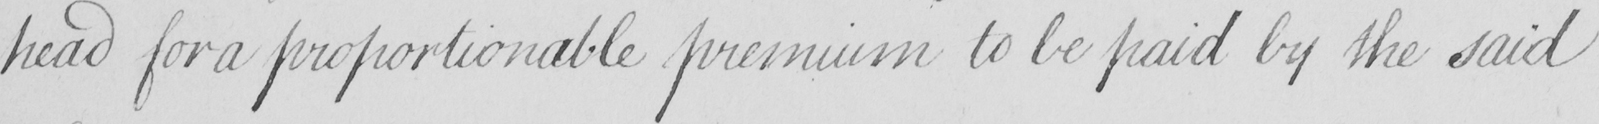What does this handwritten line say? head for a proportionable premium to be paid by the said 